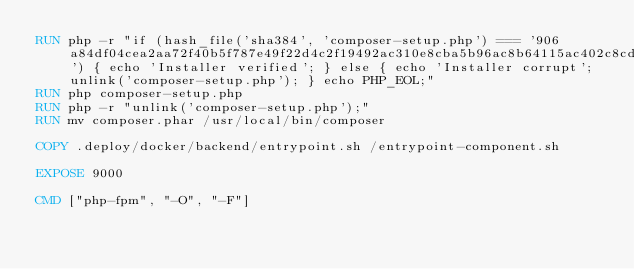<code> <loc_0><loc_0><loc_500><loc_500><_Dockerfile_>RUN php -r "if (hash_file('sha384', 'composer-setup.php') === '906a84df04cea2aa72f40b5f787e49f22d4c2f19492ac310e8cba5b96ac8b64115ac402c8cd292b8a03482574915d1a8') { echo 'Installer verified'; } else { echo 'Installer corrupt'; unlink('composer-setup.php'); } echo PHP_EOL;"
RUN php composer-setup.php
RUN php -r "unlink('composer-setup.php');"
RUN mv composer.phar /usr/local/bin/composer

COPY .deploy/docker/backend/entrypoint.sh /entrypoint-component.sh

EXPOSE 9000

CMD ["php-fpm", "-O", "-F"]
</code> 